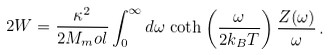<formula> <loc_0><loc_0><loc_500><loc_500>2 W = \frac { \kappa ^ { 2 } } { 2 M _ { m } o l } \int _ { 0 } ^ { \infty } d \omega \, \coth \left ( \frac { \omega } { 2 k _ { B } T } \right ) \frac { Z ( \omega ) } { \omega } \, .</formula> 